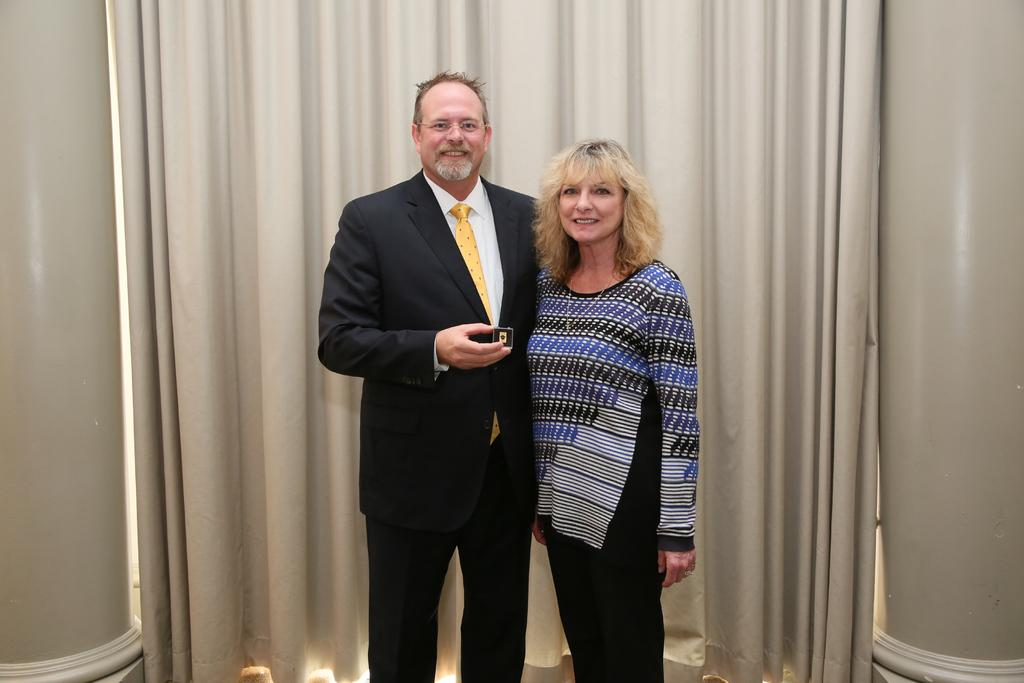How many people are in the image? There are two people in the image, a man and a woman. What are the expressions on their faces? Both the man and woman are smiling in the image. What is the man holding in the image? The man is holding an object. What can be seen in the background of the image? There are pillars and a curtain in the background of the image. What type of baseball reaction can be seen from the woman in the image? There is no baseball or any related reaction present in the image. 